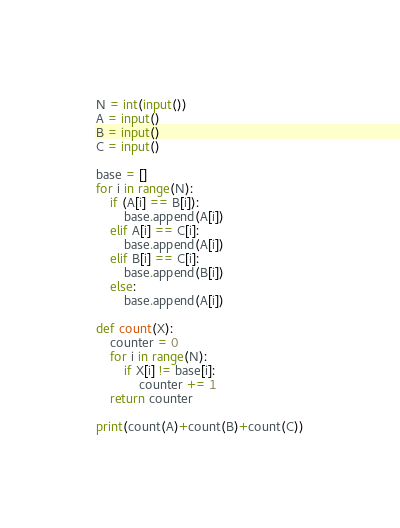<code> <loc_0><loc_0><loc_500><loc_500><_Python_>N = int(input())
A = input()
B = input()
C = input()

base = []
for i in range(N):
    if (A[i] == B[i]):
        base.append(A[i])
    elif A[i] == C[i]:
        base.append(A[i])
    elif B[i] == C[i]:
        base.append(B[i])
    else:
        base.append(A[i])

def count(X):
    counter = 0
    for i in range(N):
        if X[i] != base[i]:
            counter += 1
    return counter

print(count(A)+count(B)+count(C))</code> 